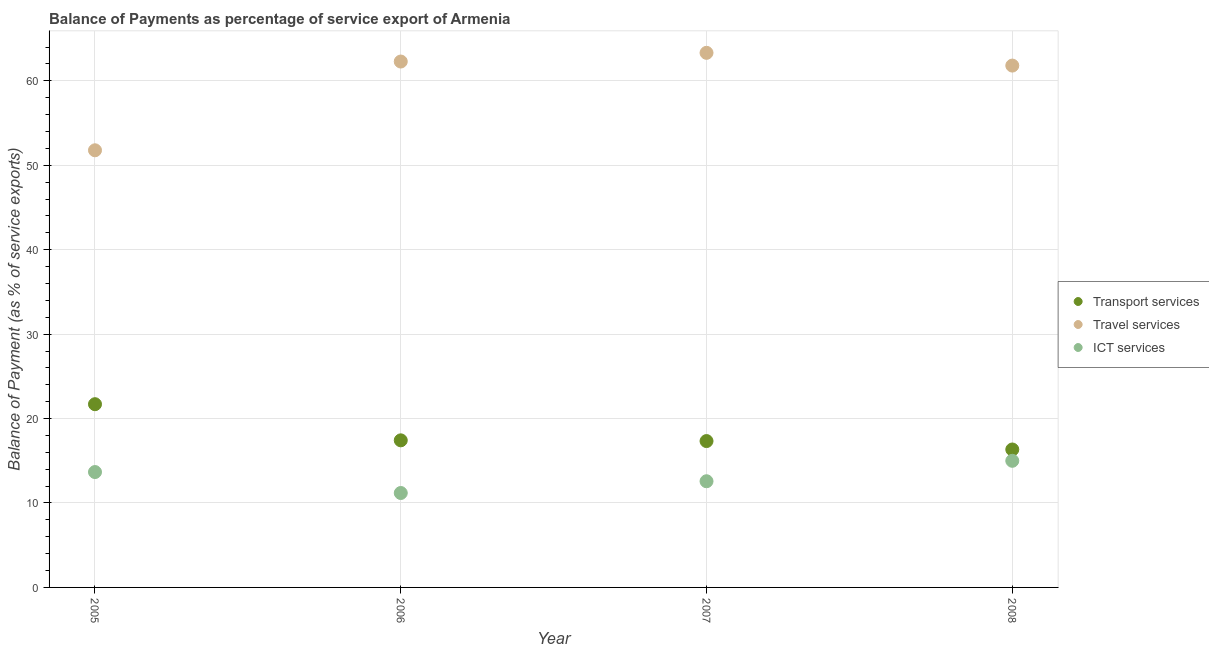How many different coloured dotlines are there?
Offer a terse response. 3. Is the number of dotlines equal to the number of legend labels?
Offer a very short reply. Yes. What is the balance of payment of ict services in 2006?
Make the answer very short. 11.18. Across all years, what is the maximum balance of payment of ict services?
Your answer should be compact. 15. Across all years, what is the minimum balance of payment of ict services?
Keep it short and to the point. 11.18. In which year was the balance of payment of travel services maximum?
Your answer should be very brief. 2007. What is the total balance of payment of transport services in the graph?
Provide a short and direct response. 72.8. What is the difference between the balance of payment of transport services in 2006 and that in 2007?
Provide a succinct answer. 0.09. What is the difference between the balance of payment of ict services in 2008 and the balance of payment of transport services in 2005?
Keep it short and to the point. -6.7. What is the average balance of payment of travel services per year?
Give a very brief answer. 59.8. In the year 2008, what is the difference between the balance of payment of transport services and balance of payment of travel services?
Your response must be concise. -45.47. What is the ratio of the balance of payment of ict services in 2006 to that in 2007?
Give a very brief answer. 0.89. Is the balance of payment of ict services in 2005 less than that in 2006?
Your answer should be compact. No. Is the difference between the balance of payment of travel services in 2006 and 2008 greater than the difference between the balance of payment of transport services in 2006 and 2008?
Make the answer very short. No. What is the difference between the highest and the second highest balance of payment of transport services?
Your answer should be compact. 4.28. What is the difference between the highest and the lowest balance of payment of transport services?
Make the answer very short. 5.36. Is the sum of the balance of payment of travel services in 2007 and 2008 greater than the maximum balance of payment of ict services across all years?
Provide a succinct answer. Yes. Is it the case that in every year, the sum of the balance of payment of transport services and balance of payment of travel services is greater than the balance of payment of ict services?
Provide a succinct answer. Yes. How many years are there in the graph?
Your response must be concise. 4. What is the difference between two consecutive major ticks on the Y-axis?
Ensure brevity in your answer.  10. Does the graph contain grids?
Ensure brevity in your answer.  Yes. Where does the legend appear in the graph?
Offer a very short reply. Center right. What is the title of the graph?
Give a very brief answer. Balance of Payments as percentage of service export of Armenia. Does "Ireland" appear as one of the legend labels in the graph?
Give a very brief answer. No. What is the label or title of the Y-axis?
Ensure brevity in your answer.  Balance of Payment (as % of service exports). What is the Balance of Payment (as % of service exports) in Transport services in 2005?
Your response must be concise. 21.7. What is the Balance of Payment (as % of service exports) in Travel services in 2005?
Your answer should be very brief. 51.78. What is the Balance of Payment (as % of service exports) in ICT services in 2005?
Ensure brevity in your answer.  13.67. What is the Balance of Payment (as % of service exports) of Transport services in 2006?
Offer a terse response. 17.42. What is the Balance of Payment (as % of service exports) of Travel services in 2006?
Offer a terse response. 62.29. What is the Balance of Payment (as % of service exports) in ICT services in 2006?
Provide a succinct answer. 11.18. What is the Balance of Payment (as % of service exports) of Transport services in 2007?
Offer a very short reply. 17.34. What is the Balance of Payment (as % of service exports) in Travel services in 2007?
Provide a short and direct response. 63.32. What is the Balance of Payment (as % of service exports) of ICT services in 2007?
Your answer should be very brief. 12.58. What is the Balance of Payment (as % of service exports) of Transport services in 2008?
Give a very brief answer. 16.34. What is the Balance of Payment (as % of service exports) of Travel services in 2008?
Give a very brief answer. 61.81. What is the Balance of Payment (as % of service exports) in ICT services in 2008?
Give a very brief answer. 15. Across all years, what is the maximum Balance of Payment (as % of service exports) in Transport services?
Your answer should be very brief. 21.7. Across all years, what is the maximum Balance of Payment (as % of service exports) of Travel services?
Provide a short and direct response. 63.32. Across all years, what is the maximum Balance of Payment (as % of service exports) of ICT services?
Offer a very short reply. 15. Across all years, what is the minimum Balance of Payment (as % of service exports) in Transport services?
Offer a very short reply. 16.34. Across all years, what is the minimum Balance of Payment (as % of service exports) of Travel services?
Give a very brief answer. 51.78. Across all years, what is the minimum Balance of Payment (as % of service exports) in ICT services?
Your response must be concise. 11.18. What is the total Balance of Payment (as % of service exports) in Transport services in the graph?
Your response must be concise. 72.8. What is the total Balance of Payment (as % of service exports) of Travel services in the graph?
Your answer should be compact. 239.2. What is the total Balance of Payment (as % of service exports) in ICT services in the graph?
Ensure brevity in your answer.  52.42. What is the difference between the Balance of Payment (as % of service exports) in Transport services in 2005 and that in 2006?
Ensure brevity in your answer.  4.28. What is the difference between the Balance of Payment (as % of service exports) in Travel services in 2005 and that in 2006?
Give a very brief answer. -10.51. What is the difference between the Balance of Payment (as % of service exports) of ICT services in 2005 and that in 2006?
Your response must be concise. 2.48. What is the difference between the Balance of Payment (as % of service exports) in Transport services in 2005 and that in 2007?
Keep it short and to the point. 4.37. What is the difference between the Balance of Payment (as % of service exports) in Travel services in 2005 and that in 2007?
Your answer should be very brief. -11.54. What is the difference between the Balance of Payment (as % of service exports) of ICT services in 2005 and that in 2007?
Offer a terse response. 1.09. What is the difference between the Balance of Payment (as % of service exports) of Transport services in 2005 and that in 2008?
Provide a succinct answer. 5.36. What is the difference between the Balance of Payment (as % of service exports) in Travel services in 2005 and that in 2008?
Your answer should be compact. -10.03. What is the difference between the Balance of Payment (as % of service exports) in ICT services in 2005 and that in 2008?
Make the answer very short. -1.33. What is the difference between the Balance of Payment (as % of service exports) of Transport services in 2006 and that in 2007?
Provide a succinct answer. 0.09. What is the difference between the Balance of Payment (as % of service exports) in Travel services in 2006 and that in 2007?
Offer a terse response. -1.03. What is the difference between the Balance of Payment (as % of service exports) of ICT services in 2006 and that in 2007?
Make the answer very short. -1.39. What is the difference between the Balance of Payment (as % of service exports) in Transport services in 2006 and that in 2008?
Ensure brevity in your answer.  1.08. What is the difference between the Balance of Payment (as % of service exports) of Travel services in 2006 and that in 2008?
Your answer should be compact. 0.48. What is the difference between the Balance of Payment (as % of service exports) in ICT services in 2006 and that in 2008?
Offer a very short reply. -3.81. What is the difference between the Balance of Payment (as % of service exports) in Transport services in 2007 and that in 2008?
Your answer should be very brief. 1. What is the difference between the Balance of Payment (as % of service exports) of Travel services in 2007 and that in 2008?
Offer a terse response. 1.51. What is the difference between the Balance of Payment (as % of service exports) of ICT services in 2007 and that in 2008?
Make the answer very short. -2.42. What is the difference between the Balance of Payment (as % of service exports) in Transport services in 2005 and the Balance of Payment (as % of service exports) in Travel services in 2006?
Give a very brief answer. -40.59. What is the difference between the Balance of Payment (as % of service exports) in Transport services in 2005 and the Balance of Payment (as % of service exports) in ICT services in 2006?
Make the answer very short. 10.52. What is the difference between the Balance of Payment (as % of service exports) of Travel services in 2005 and the Balance of Payment (as % of service exports) of ICT services in 2006?
Make the answer very short. 40.59. What is the difference between the Balance of Payment (as % of service exports) of Transport services in 2005 and the Balance of Payment (as % of service exports) of Travel services in 2007?
Offer a terse response. -41.62. What is the difference between the Balance of Payment (as % of service exports) in Transport services in 2005 and the Balance of Payment (as % of service exports) in ICT services in 2007?
Your answer should be compact. 9.13. What is the difference between the Balance of Payment (as % of service exports) of Travel services in 2005 and the Balance of Payment (as % of service exports) of ICT services in 2007?
Your response must be concise. 39.2. What is the difference between the Balance of Payment (as % of service exports) of Transport services in 2005 and the Balance of Payment (as % of service exports) of Travel services in 2008?
Your answer should be compact. -40.11. What is the difference between the Balance of Payment (as % of service exports) in Transport services in 2005 and the Balance of Payment (as % of service exports) in ICT services in 2008?
Provide a short and direct response. 6.7. What is the difference between the Balance of Payment (as % of service exports) of Travel services in 2005 and the Balance of Payment (as % of service exports) of ICT services in 2008?
Your answer should be compact. 36.78. What is the difference between the Balance of Payment (as % of service exports) in Transport services in 2006 and the Balance of Payment (as % of service exports) in Travel services in 2007?
Your response must be concise. -45.9. What is the difference between the Balance of Payment (as % of service exports) in Transport services in 2006 and the Balance of Payment (as % of service exports) in ICT services in 2007?
Provide a short and direct response. 4.85. What is the difference between the Balance of Payment (as % of service exports) of Travel services in 2006 and the Balance of Payment (as % of service exports) of ICT services in 2007?
Make the answer very short. 49.71. What is the difference between the Balance of Payment (as % of service exports) of Transport services in 2006 and the Balance of Payment (as % of service exports) of Travel services in 2008?
Your response must be concise. -44.39. What is the difference between the Balance of Payment (as % of service exports) in Transport services in 2006 and the Balance of Payment (as % of service exports) in ICT services in 2008?
Your response must be concise. 2.42. What is the difference between the Balance of Payment (as % of service exports) in Travel services in 2006 and the Balance of Payment (as % of service exports) in ICT services in 2008?
Provide a short and direct response. 47.29. What is the difference between the Balance of Payment (as % of service exports) in Transport services in 2007 and the Balance of Payment (as % of service exports) in Travel services in 2008?
Your answer should be very brief. -44.48. What is the difference between the Balance of Payment (as % of service exports) in Transport services in 2007 and the Balance of Payment (as % of service exports) in ICT services in 2008?
Make the answer very short. 2.34. What is the difference between the Balance of Payment (as % of service exports) of Travel services in 2007 and the Balance of Payment (as % of service exports) of ICT services in 2008?
Offer a very short reply. 48.32. What is the average Balance of Payment (as % of service exports) in Transport services per year?
Your response must be concise. 18.2. What is the average Balance of Payment (as % of service exports) in Travel services per year?
Offer a terse response. 59.8. What is the average Balance of Payment (as % of service exports) in ICT services per year?
Ensure brevity in your answer.  13.11. In the year 2005, what is the difference between the Balance of Payment (as % of service exports) of Transport services and Balance of Payment (as % of service exports) of Travel services?
Keep it short and to the point. -30.07. In the year 2005, what is the difference between the Balance of Payment (as % of service exports) of Transport services and Balance of Payment (as % of service exports) of ICT services?
Your answer should be very brief. 8.04. In the year 2005, what is the difference between the Balance of Payment (as % of service exports) of Travel services and Balance of Payment (as % of service exports) of ICT services?
Keep it short and to the point. 38.11. In the year 2006, what is the difference between the Balance of Payment (as % of service exports) in Transport services and Balance of Payment (as % of service exports) in Travel services?
Your response must be concise. -44.87. In the year 2006, what is the difference between the Balance of Payment (as % of service exports) of Transport services and Balance of Payment (as % of service exports) of ICT services?
Make the answer very short. 6.24. In the year 2006, what is the difference between the Balance of Payment (as % of service exports) of Travel services and Balance of Payment (as % of service exports) of ICT services?
Give a very brief answer. 51.11. In the year 2007, what is the difference between the Balance of Payment (as % of service exports) of Transport services and Balance of Payment (as % of service exports) of Travel services?
Keep it short and to the point. -45.98. In the year 2007, what is the difference between the Balance of Payment (as % of service exports) in Transport services and Balance of Payment (as % of service exports) in ICT services?
Offer a terse response. 4.76. In the year 2007, what is the difference between the Balance of Payment (as % of service exports) of Travel services and Balance of Payment (as % of service exports) of ICT services?
Give a very brief answer. 50.74. In the year 2008, what is the difference between the Balance of Payment (as % of service exports) in Transport services and Balance of Payment (as % of service exports) in Travel services?
Give a very brief answer. -45.47. In the year 2008, what is the difference between the Balance of Payment (as % of service exports) in Transport services and Balance of Payment (as % of service exports) in ICT services?
Give a very brief answer. 1.34. In the year 2008, what is the difference between the Balance of Payment (as % of service exports) of Travel services and Balance of Payment (as % of service exports) of ICT services?
Keep it short and to the point. 46.81. What is the ratio of the Balance of Payment (as % of service exports) in Transport services in 2005 to that in 2006?
Make the answer very short. 1.25. What is the ratio of the Balance of Payment (as % of service exports) in Travel services in 2005 to that in 2006?
Provide a succinct answer. 0.83. What is the ratio of the Balance of Payment (as % of service exports) in ICT services in 2005 to that in 2006?
Your response must be concise. 1.22. What is the ratio of the Balance of Payment (as % of service exports) in Transport services in 2005 to that in 2007?
Your response must be concise. 1.25. What is the ratio of the Balance of Payment (as % of service exports) in Travel services in 2005 to that in 2007?
Your response must be concise. 0.82. What is the ratio of the Balance of Payment (as % of service exports) of ICT services in 2005 to that in 2007?
Make the answer very short. 1.09. What is the ratio of the Balance of Payment (as % of service exports) of Transport services in 2005 to that in 2008?
Provide a succinct answer. 1.33. What is the ratio of the Balance of Payment (as % of service exports) in Travel services in 2005 to that in 2008?
Your answer should be very brief. 0.84. What is the ratio of the Balance of Payment (as % of service exports) of ICT services in 2005 to that in 2008?
Make the answer very short. 0.91. What is the ratio of the Balance of Payment (as % of service exports) of Travel services in 2006 to that in 2007?
Provide a succinct answer. 0.98. What is the ratio of the Balance of Payment (as % of service exports) of ICT services in 2006 to that in 2007?
Keep it short and to the point. 0.89. What is the ratio of the Balance of Payment (as % of service exports) in Transport services in 2006 to that in 2008?
Offer a terse response. 1.07. What is the ratio of the Balance of Payment (as % of service exports) of Travel services in 2006 to that in 2008?
Your response must be concise. 1.01. What is the ratio of the Balance of Payment (as % of service exports) in ICT services in 2006 to that in 2008?
Give a very brief answer. 0.75. What is the ratio of the Balance of Payment (as % of service exports) of Transport services in 2007 to that in 2008?
Provide a short and direct response. 1.06. What is the ratio of the Balance of Payment (as % of service exports) of Travel services in 2007 to that in 2008?
Offer a very short reply. 1.02. What is the ratio of the Balance of Payment (as % of service exports) of ICT services in 2007 to that in 2008?
Make the answer very short. 0.84. What is the difference between the highest and the second highest Balance of Payment (as % of service exports) of Transport services?
Keep it short and to the point. 4.28. What is the difference between the highest and the second highest Balance of Payment (as % of service exports) in Travel services?
Ensure brevity in your answer.  1.03. What is the difference between the highest and the second highest Balance of Payment (as % of service exports) in ICT services?
Offer a very short reply. 1.33. What is the difference between the highest and the lowest Balance of Payment (as % of service exports) in Transport services?
Your answer should be compact. 5.36. What is the difference between the highest and the lowest Balance of Payment (as % of service exports) of Travel services?
Provide a succinct answer. 11.54. What is the difference between the highest and the lowest Balance of Payment (as % of service exports) in ICT services?
Provide a succinct answer. 3.81. 